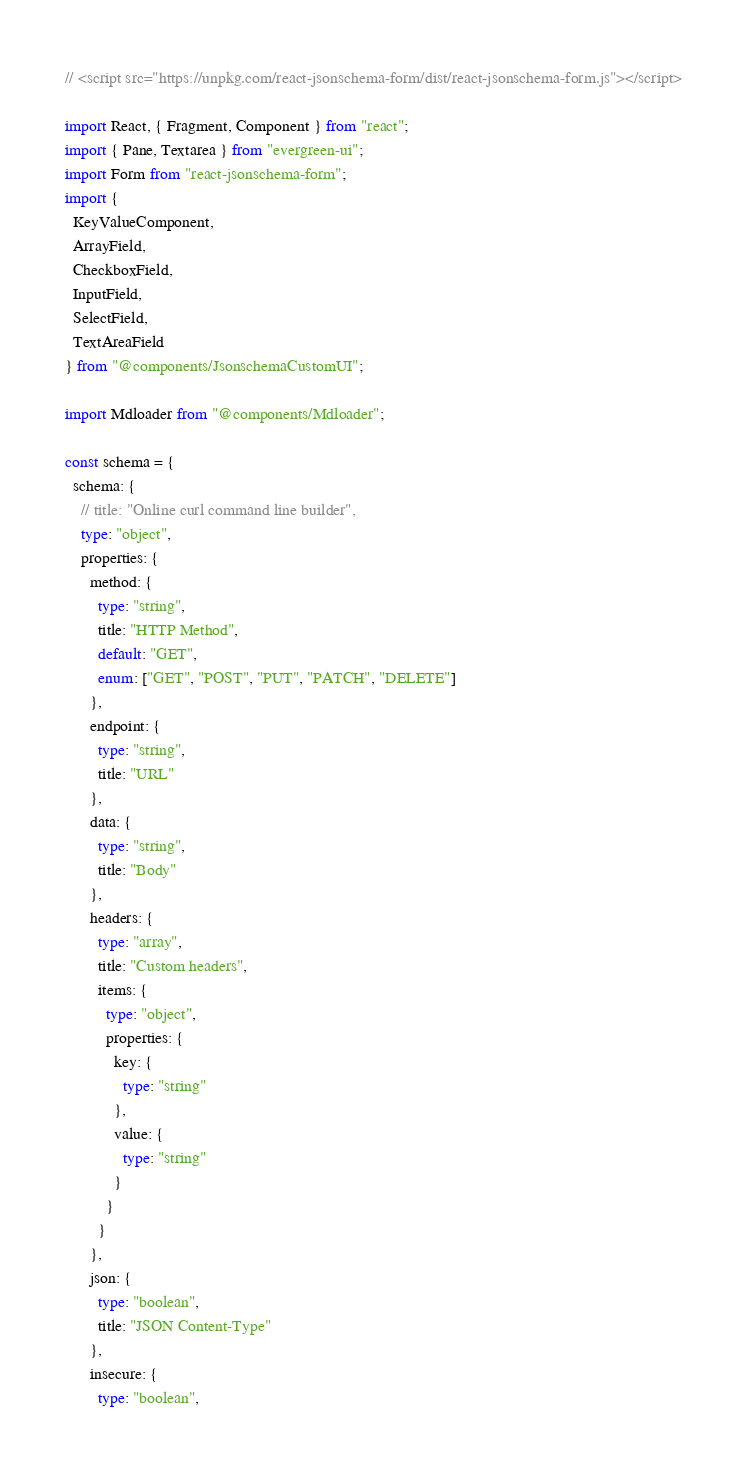<code> <loc_0><loc_0><loc_500><loc_500><_TypeScript_>// <script src="https://unpkg.com/react-jsonschema-form/dist/react-jsonschema-form.js"></script>

import React, { Fragment, Component } from "react";
import { Pane, Textarea } from "evergreen-ui";
import Form from "react-jsonschema-form";
import {
  KeyValueComponent,
  ArrayField,
  CheckboxField,
  InputField,
  SelectField,
  TextAreaField
} from "@components/JsonschemaCustomUI";

import Mdloader from "@components/Mdloader";

const schema = {
  schema: {
    // title: "Online curl command line builder",
    type: "object",
    properties: {
      method: {
        type: "string",
        title: "HTTP Method",
        default: "GET",
        enum: ["GET", "POST", "PUT", "PATCH", "DELETE"]
      },
      endpoint: {
        type: "string",
        title: "URL"
      },
      data: {
        type: "string",
        title: "Body"
      },
      headers: {
        type: "array",
        title: "Custom headers",
        items: {
          type: "object",
          properties: {
            key: {
              type: "string"
            },
            value: {
              type: "string"
            }
          }
        }
      },
      json: {
        type: "boolean",
        title: "JSON Content-Type"
      },
      insecure: {
        type: "boolean",</code> 